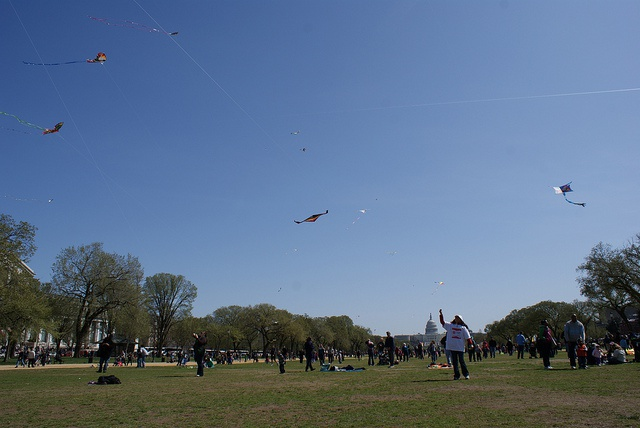Describe the objects in this image and their specific colors. I can see people in darkblue, black, darkgreen, gray, and maroon tones, people in darkblue, black, and navy tones, people in darkblue, black, maroon, gray, and navy tones, kite in darkblue, blue, and purple tones, and people in darkblue, black, maroon, gray, and darkgreen tones in this image. 